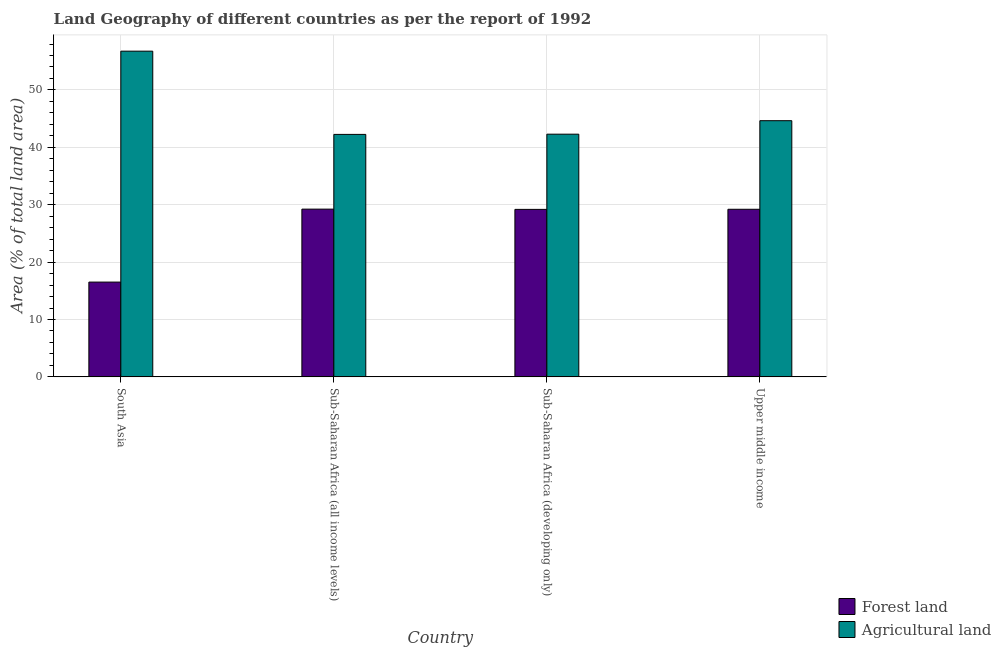How many different coloured bars are there?
Give a very brief answer. 2. How many groups of bars are there?
Make the answer very short. 4. Are the number of bars per tick equal to the number of legend labels?
Your answer should be compact. Yes. How many bars are there on the 3rd tick from the left?
Offer a very short reply. 2. How many bars are there on the 3rd tick from the right?
Keep it short and to the point. 2. What is the label of the 4th group of bars from the left?
Provide a succinct answer. Upper middle income. In how many cases, is the number of bars for a given country not equal to the number of legend labels?
Provide a short and direct response. 0. What is the percentage of land area under forests in Upper middle income?
Your answer should be compact. 29.2. Across all countries, what is the maximum percentage of land area under forests?
Your answer should be very brief. 29.23. Across all countries, what is the minimum percentage of land area under agriculture?
Ensure brevity in your answer.  42.25. In which country was the percentage of land area under forests maximum?
Give a very brief answer. Sub-Saharan Africa (all income levels). What is the total percentage of land area under forests in the graph?
Give a very brief answer. 104.13. What is the difference between the percentage of land area under forests in South Asia and that in Upper middle income?
Offer a very short reply. -12.69. What is the difference between the percentage of land area under forests in Sub-Saharan Africa (all income levels) and the percentage of land area under agriculture in South Asia?
Provide a short and direct response. -27.53. What is the average percentage of land area under agriculture per country?
Give a very brief answer. 46.48. What is the difference between the percentage of land area under forests and percentage of land area under agriculture in Sub-Saharan Africa (all income levels)?
Your response must be concise. -13.02. In how many countries, is the percentage of land area under forests greater than 54 %?
Your response must be concise. 0. What is the ratio of the percentage of land area under forests in Sub-Saharan Africa (all income levels) to that in Sub-Saharan Africa (developing only)?
Offer a very short reply. 1. What is the difference between the highest and the second highest percentage of land area under agriculture?
Your answer should be compact. 12.12. What is the difference between the highest and the lowest percentage of land area under agriculture?
Your answer should be compact. 14.5. In how many countries, is the percentage of land area under agriculture greater than the average percentage of land area under agriculture taken over all countries?
Your response must be concise. 1. Is the sum of the percentage of land area under agriculture in South Asia and Sub-Saharan Africa (all income levels) greater than the maximum percentage of land area under forests across all countries?
Offer a terse response. Yes. What does the 2nd bar from the left in Upper middle income represents?
Offer a terse response. Agricultural land. What does the 1st bar from the right in Sub-Saharan Africa (developing only) represents?
Keep it short and to the point. Agricultural land. Are the values on the major ticks of Y-axis written in scientific E-notation?
Offer a terse response. No. Does the graph contain any zero values?
Give a very brief answer. No. Does the graph contain grids?
Give a very brief answer. Yes. How many legend labels are there?
Your response must be concise. 2. What is the title of the graph?
Give a very brief answer. Land Geography of different countries as per the report of 1992. What is the label or title of the Y-axis?
Offer a very short reply. Area (% of total land area). What is the Area (% of total land area) in Forest land in South Asia?
Your answer should be very brief. 16.52. What is the Area (% of total land area) in Agricultural land in South Asia?
Provide a short and direct response. 56.75. What is the Area (% of total land area) of Forest land in Sub-Saharan Africa (all income levels)?
Your answer should be compact. 29.23. What is the Area (% of total land area) of Agricultural land in Sub-Saharan Africa (all income levels)?
Your answer should be very brief. 42.25. What is the Area (% of total land area) of Forest land in Sub-Saharan Africa (developing only)?
Keep it short and to the point. 29.18. What is the Area (% of total land area) in Agricultural land in Sub-Saharan Africa (developing only)?
Your answer should be compact. 42.29. What is the Area (% of total land area) in Forest land in Upper middle income?
Your answer should be very brief. 29.2. What is the Area (% of total land area) in Agricultural land in Upper middle income?
Provide a succinct answer. 44.64. Across all countries, what is the maximum Area (% of total land area) in Forest land?
Provide a short and direct response. 29.23. Across all countries, what is the maximum Area (% of total land area) in Agricultural land?
Provide a short and direct response. 56.75. Across all countries, what is the minimum Area (% of total land area) in Forest land?
Keep it short and to the point. 16.52. Across all countries, what is the minimum Area (% of total land area) in Agricultural land?
Ensure brevity in your answer.  42.25. What is the total Area (% of total land area) of Forest land in the graph?
Your answer should be compact. 104.13. What is the total Area (% of total land area) in Agricultural land in the graph?
Provide a succinct answer. 185.93. What is the difference between the Area (% of total land area) in Forest land in South Asia and that in Sub-Saharan Africa (all income levels)?
Provide a succinct answer. -12.71. What is the difference between the Area (% of total land area) in Agricultural land in South Asia and that in Sub-Saharan Africa (all income levels)?
Provide a short and direct response. 14.5. What is the difference between the Area (% of total land area) of Forest land in South Asia and that in Sub-Saharan Africa (developing only)?
Provide a succinct answer. -12.67. What is the difference between the Area (% of total land area) in Agricultural land in South Asia and that in Sub-Saharan Africa (developing only)?
Keep it short and to the point. 14.47. What is the difference between the Area (% of total land area) in Forest land in South Asia and that in Upper middle income?
Give a very brief answer. -12.69. What is the difference between the Area (% of total land area) in Agricultural land in South Asia and that in Upper middle income?
Keep it short and to the point. 12.12. What is the difference between the Area (% of total land area) of Forest land in Sub-Saharan Africa (all income levels) and that in Sub-Saharan Africa (developing only)?
Make the answer very short. 0.04. What is the difference between the Area (% of total land area) in Agricultural land in Sub-Saharan Africa (all income levels) and that in Sub-Saharan Africa (developing only)?
Offer a very short reply. -0.04. What is the difference between the Area (% of total land area) in Forest land in Sub-Saharan Africa (all income levels) and that in Upper middle income?
Ensure brevity in your answer.  0.03. What is the difference between the Area (% of total land area) in Agricultural land in Sub-Saharan Africa (all income levels) and that in Upper middle income?
Keep it short and to the point. -2.39. What is the difference between the Area (% of total land area) of Forest land in Sub-Saharan Africa (developing only) and that in Upper middle income?
Make the answer very short. -0.02. What is the difference between the Area (% of total land area) in Agricultural land in Sub-Saharan Africa (developing only) and that in Upper middle income?
Your answer should be compact. -2.35. What is the difference between the Area (% of total land area) of Forest land in South Asia and the Area (% of total land area) of Agricultural land in Sub-Saharan Africa (all income levels)?
Provide a succinct answer. -25.74. What is the difference between the Area (% of total land area) of Forest land in South Asia and the Area (% of total land area) of Agricultural land in Sub-Saharan Africa (developing only)?
Your answer should be compact. -25.77. What is the difference between the Area (% of total land area) in Forest land in South Asia and the Area (% of total land area) in Agricultural land in Upper middle income?
Offer a terse response. -28.12. What is the difference between the Area (% of total land area) of Forest land in Sub-Saharan Africa (all income levels) and the Area (% of total land area) of Agricultural land in Sub-Saharan Africa (developing only)?
Give a very brief answer. -13.06. What is the difference between the Area (% of total land area) in Forest land in Sub-Saharan Africa (all income levels) and the Area (% of total land area) in Agricultural land in Upper middle income?
Offer a terse response. -15.41. What is the difference between the Area (% of total land area) in Forest land in Sub-Saharan Africa (developing only) and the Area (% of total land area) in Agricultural land in Upper middle income?
Give a very brief answer. -15.45. What is the average Area (% of total land area) of Forest land per country?
Provide a succinct answer. 26.03. What is the average Area (% of total land area) in Agricultural land per country?
Offer a terse response. 46.48. What is the difference between the Area (% of total land area) of Forest land and Area (% of total land area) of Agricultural land in South Asia?
Your answer should be very brief. -40.24. What is the difference between the Area (% of total land area) of Forest land and Area (% of total land area) of Agricultural land in Sub-Saharan Africa (all income levels)?
Ensure brevity in your answer.  -13.02. What is the difference between the Area (% of total land area) of Forest land and Area (% of total land area) of Agricultural land in Sub-Saharan Africa (developing only)?
Your response must be concise. -13.1. What is the difference between the Area (% of total land area) in Forest land and Area (% of total land area) in Agricultural land in Upper middle income?
Offer a terse response. -15.44. What is the ratio of the Area (% of total land area) in Forest land in South Asia to that in Sub-Saharan Africa (all income levels)?
Keep it short and to the point. 0.56. What is the ratio of the Area (% of total land area) of Agricultural land in South Asia to that in Sub-Saharan Africa (all income levels)?
Your response must be concise. 1.34. What is the ratio of the Area (% of total land area) of Forest land in South Asia to that in Sub-Saharan Africa (developing only)?
Offer a very short reply. 0.57. What is the ratio of the Area (% of total land area) in Agricultural land in South Asia to that in Sub-Saharan Africa (developing only)?
Make the answer very short. 1.34. What is the ratio of the Area (% of total land area) in Forest land in South Asia to that in Upper middle income?
Your answer should be very brief. 0.57. What is the ratio of the Area (% of total land area) of Agricultural land in South Asia to that in Upper middle income?
Offer a very short reply. 1.27. What is the ratio of the Area (% of total land area) of Agricultural land in Sub-Saharan Africa (all income levels) to that in Sub-Saharan Africa (developing only)?
Give a very brief answer. 1. What is the ratio of the Area (% of total land area) in Forest land in Sub-Saharan Africa (all income levels) to that in Upper middle income?
Provide a succinct answer. 1. What is the ratio of the Area (% of total land area) in Agricultural land in Sub-Saharan Africa (all income levels) to that in Upper middle income?
Give a very brief answer. 0.95. What is the ratio of the Area (% of total land area) in Forest land in Sub-Saharan Africa (developing only) to that in Upper middle income?
Offer a terse response. 1. What is the ratio of the Area (% of total land area) in Agricultural land in Sub-Saharan Africa (developing only) to that in Upper middle income?
Your answer should be compact. 0.95. What is the difference between the highest and the second highest Area (% of total land area) of Forest land?
Offer a very short reply. 0.03. What is the difference between the highest and the second highest Area (% of total land area) of Agricultural land?
Give a very brief answer. 12.12. What is the difference between the highest and the lowest Area (% of total land area) of Forest land?
Give a very brief answer. 12.71. What is the difference between the highest and the lowest Area (% of total land area) of Agricultural land?
Provide a succinct answer. 14.5. 